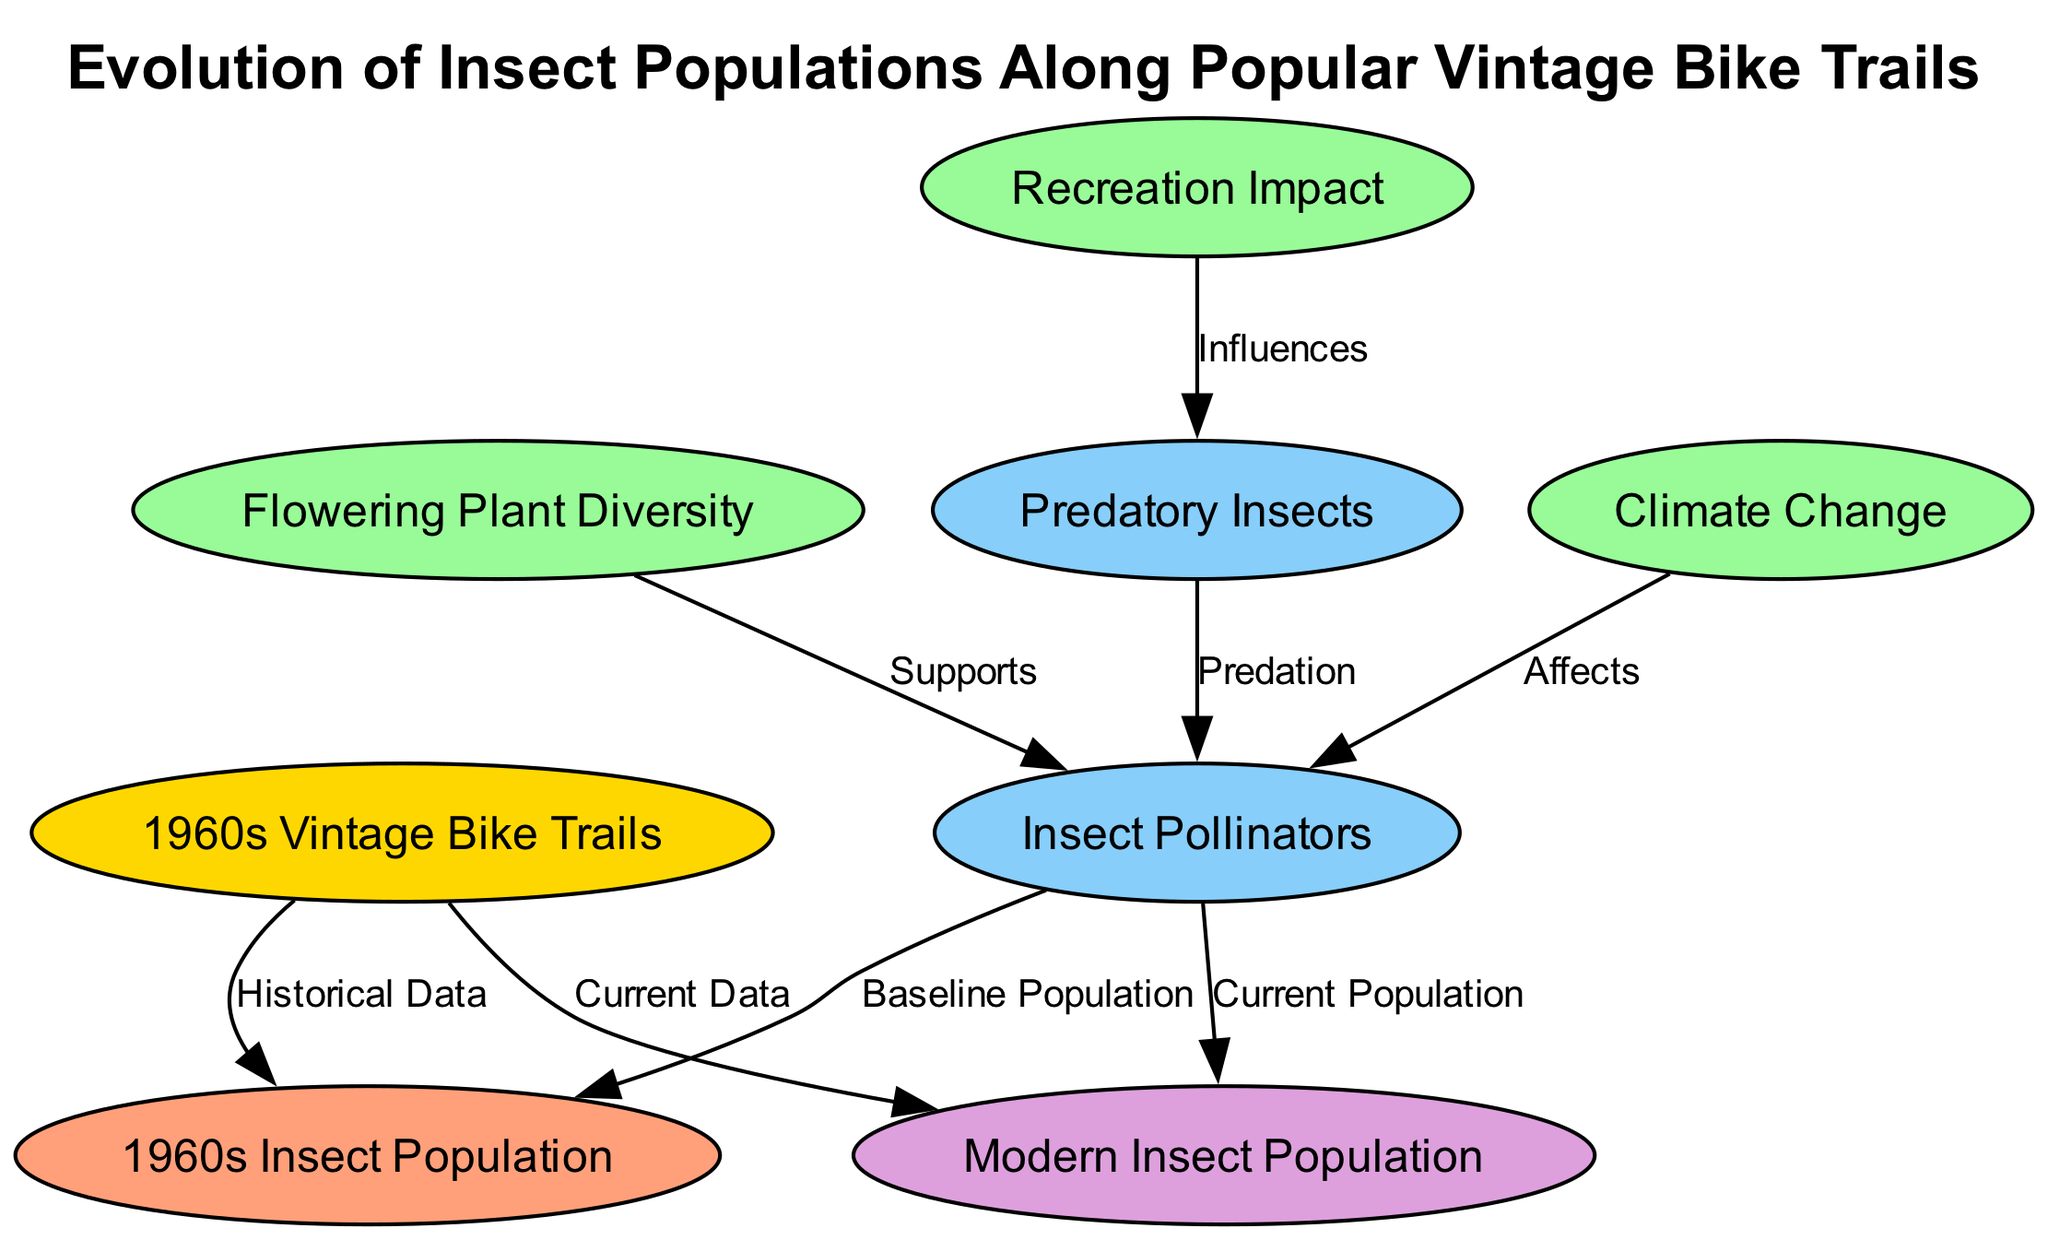What is the title of the diagram? The title of the diagram is provided at the top and is labeled as "Evolution of Insect Populations Along Popular Vintage Bike Trails."
Answer: Evolution of Insect Populations Along Popular Vintage Bike Trails How many nodes are present in the diagram? Counting the nodes listed in the dataset above, there are a total of 8 nodes in the diagram.
Answer: 8 What type is the node labeled 'Flowering Plant Diversity'? The type of the node labeled 'Flowering Plant Diversity' is categorized as 'factor', as indicated in the node data.
Answer: factor What relationship exists between 'Flowering Plant Diversity' and 'Insect Pollinators'? The diagram shows that 'Flowering Plant Diversity' supports 'Insect Pollinators', which is a direct connection indicated by the labeled edge.
Answer: Supports Which node represents the current insect population? The node labeled as 'Modern Insect Population' signifies the current insect population according to the current data node type.
Answer: Modern Insect Population How does 'Climate Change' affect 'Insect Pollinators'? According to the diagram, 'Climate Change' affects 'Insect Pollinators', establishing an adverse influence on their population dynamics.
Answer: Affects What is the relationship between 'Predatory Insects' and 'Insect Pollinators'? The diagram indicates that the relationship between 'Predatory Insects' and 'Insect Pollinators' is predation, implying a negative impact of predatory species on pollinator numbers.
Answer: Predation What does 'Recreation Impact' influence in the diagram? The diagram shows that 'Recreation Impact' influences 'Predatory Insects', demonstrating how human activities and recreation may change the dynamics of predator populations.
Answer: Influences Which nodes belong to the historical data category? The nodes classified under the historical data category are '1960s Insect Population', as it specifically mentions the historical context of insect populations.
Answer: 1960s Insect Population 